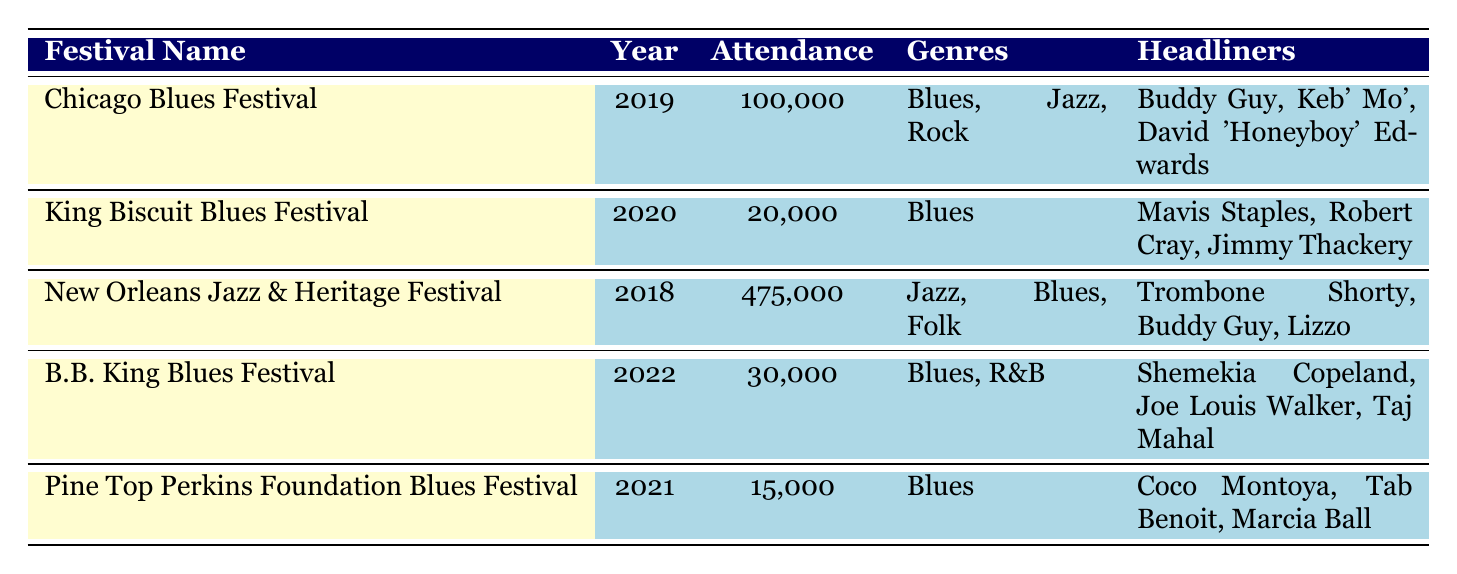What was the attendance at the Chicago Blues Festival in 2019? The table lists the Chicago Blues Festival under the row for the year 2019, showing an attendance of 100,000.
Answer: 100,000 Which festival had the highest attendance and what was it? By reviewing the attendance figures in the table, the New Orleans Jazz & Heritage Festival had the highest attendance at 475,000.
Answer: New Orleans Jazz & Heritage Festival, 475,000 Did the King Biscuit Blues Festival feature any genres besides Blues? The table indicates that the King Biscuit Blues Festival only featured the Blues genre, without any additional genres listed.
Answer: No What is the total attendance across all festivals listed in the table? The total attendance is the sum of the attendance from all festivals: (100,000 + 20,000 + 475,000 + 30,000 + 15,000) = 640,000.
Answer: 640,000 How many festivals featured Blues music alongside other genres? The Chicago Blues Festival and the B.B. King Blues Festival featured Blues music alongside other genres, which totals to 2 festivals.
Answer: 2 What was the median attendance figure among the festivals listed? To find the median, list the attendances in order: 15,000; 20,000; 30,000; 100,000; 475,000. The median value is the middle number, which is 30,000.
Answer: 30,000 Which festival held in 2022 had the lowest attendance? The B.B. King Blues Festival held in 2022 had the lowest attendance of 30,000 compared to the other festivals listed for that year.
Answer: B.B. King Blues Festival, 30,000 Did any festival feature only Blues music? Yes, both the King Biscuit Blues Festival and the Pine Top Perkins Foundation Blues Festival featured solely Blues music according to the table.
Answer: Yes 